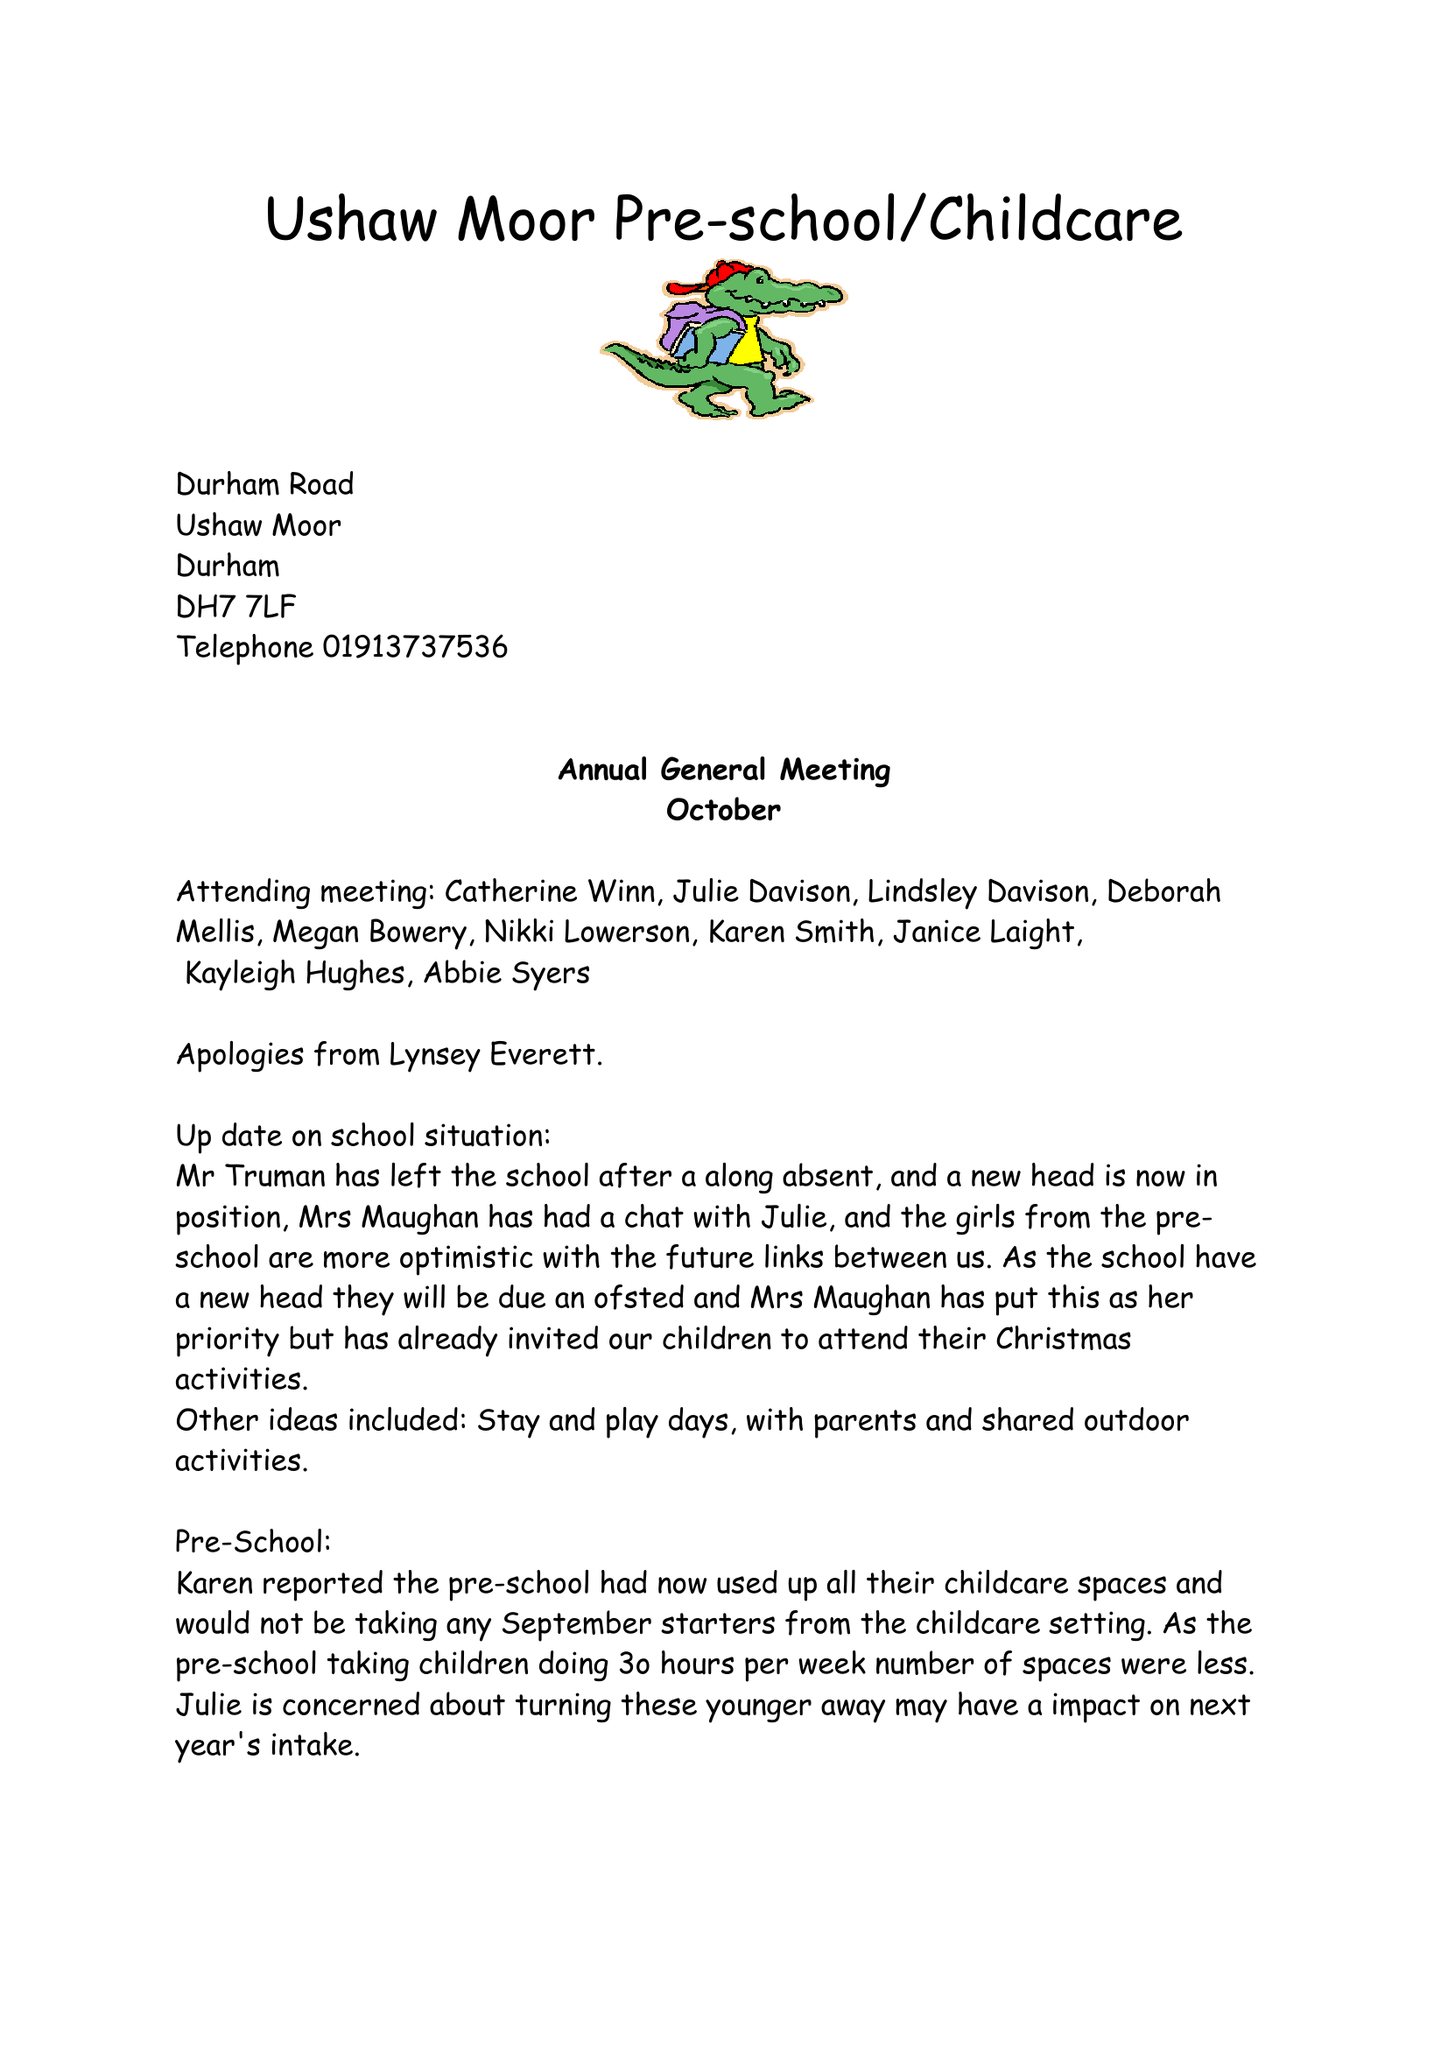What is the value for the charity_number?
Answer the question using a single word or phrase. 1072461 